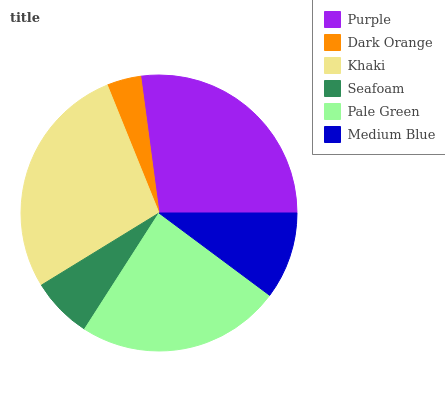Is Dark Orange the minimum?
Answer yes or no. Yes. Is Khaki the maximum?
Answer yes or no. Yes. Is Khaki the minimum?
Answer yes or no. No. Is Dark Orange the maximum?
Answer yes or no. No. Is Khaki greater than Dark Orange?
Answer yes or no. Yes. Is Dark Orange less than Khaki?
Answer yes or no. Yes. Is Dark Orange greater than Khaki?
Answer yes or no. No. Is Khaki less than Dark Orange?
Answer yes or no. No. Is Pale Green the high median?
Answer yes or no. Yes. Is Medium Blue the low median?
Answer yes or no. Yes. Is Medium Blue the high median?
Answer yes or no. No. Is Pale Green the low median?
Answer yes or no. No. 